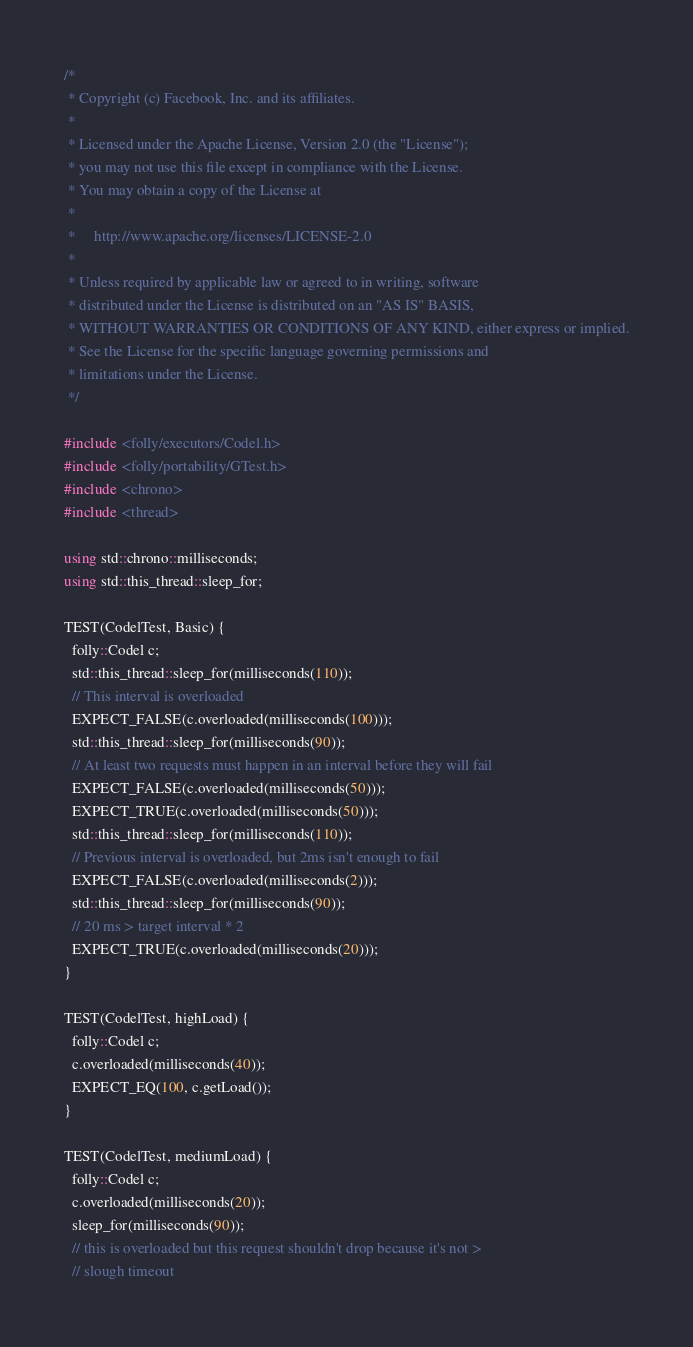<code> <loc_0><loc_0><loc_500><loc_500><_C++_>/*
 * Copyright (c) Facebook, Inc. and its affiliates.
 *
 * Licensed under the Apache License, Version 2.0 (the "License");
 * you may not use this file except in compliance with the License.
 * You may obtain a copy of the License at
 *
 *     http://www.apache.org/licenses/LICENSE-2.0
 *
 * Unless required by applicable law or agreed to in writing, software
 * distributed under the License is distributed on an "AS IS" BASIS,
 * WITHOUT WARRANTIES OR CONDITIONS OF ANY KIND, either express or implied.
 * See the License for the specific language governing permissions and
 * limitations under the License.
 */

#include <folly/executors/Codel.h>
#include <folly/portability/GTest.h>
#include <chrono>
#include <thread>

using std::chrono::milliseconds;
using std::this_thread::sleep_for;

TEST(CodelTest, Basic) {
  folly::Codel c;
  std::this_thread::sleep_for(milliseconds(110));
  // This interval is overloaded
  EXPECT_FALSE(c.overloaded(milliseconds(100)));
  std::this_thread::sleep_for(milliseconds(90));
  // At least two requests must happen in an interval before they will fail
  EXPECT_FALSE(c.overloaded(milliseconds(50)));
  EXPECT_TRUE(c.overloaded(milliseconds(50)));
  std::this_thread::sleep_for(milliseconds(110));
  // Previous interval is overloaded, but 2ms isn't enough to fail
  EXPECT_FALSE(c.overloaded(milliseconds(2)));
  std::this_thread::sleep_for(milliseconds(90));
  // 20 ms > target interval * 2
  EXPECT_TRUE(c.overloaded(milliseconds(20)));
}

TEST(CodelTest, highLoad) {
  folly::Codel c;
  c.overloaded(milliseconds(40));
  EXPECT_EQ(100, c.getLoad());
}

TEST(CodelTest, mediumLoad) {
  folly::Codel c;
  c.overloaded(milliseconds(20));
  sleep_for(milliseconds(90));
  // this is overloaded but this request shouldn't drop because it's not >
  // slough timeout</code> 